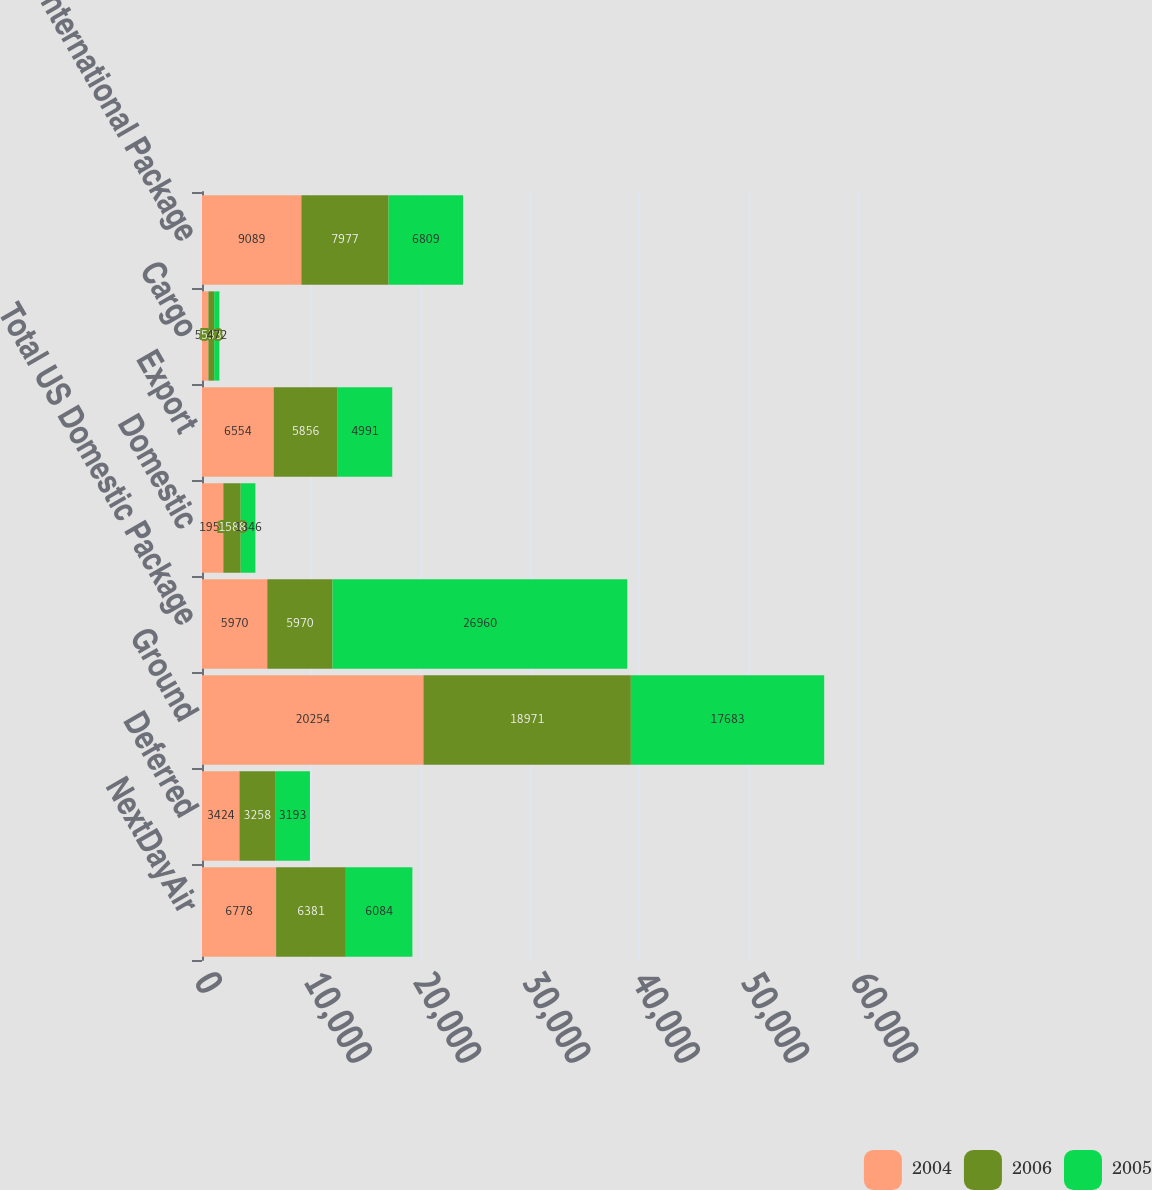Convert chart to OTSL. <chart><loc_0><loc_0><loc_500><loc_500><stacked_bar_chart><ecel><fcel>NextDayAir<fcel>Deferred<fcel>Ground<fcel>Total US Domestic Package<fcel>Domestic<fcel>Export<fcel>Cargo<fcel>Total International Package<nl><fcel>2004<fcel>6778<fcel>3424<fcel>20254<fcel>5970<fcel>1950<fcel>6554<fcel>585<fcel>9089<nl><fcel>2006<fcel>6381<fcel>3258<fcel>18971<fcel>5970<fcel>1588<fcel>5856<fcel>533<fcel>7977<nl><fcel>2005<fcel>6084<fcel>3193<fcel>17683<fcel>26960<fcel>1346<fcel>4991<fcel>472<fcel>6809<nl></chart> 